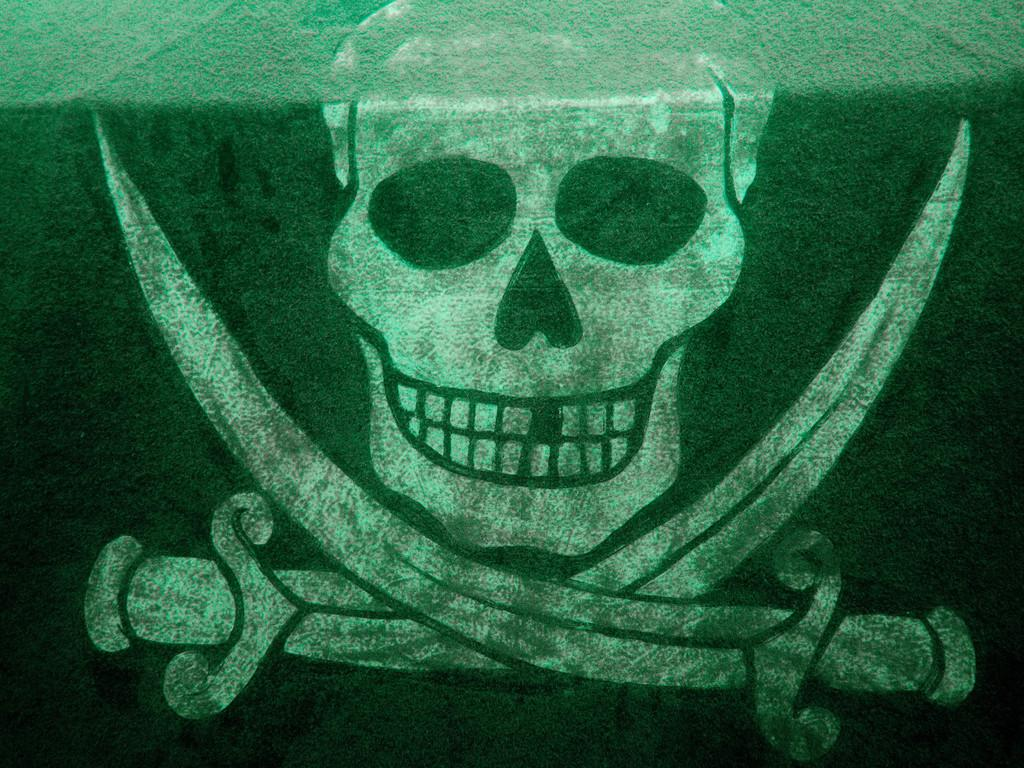Where was the image taken? The image was taken on the ground. What can be seen painted on the grass in the image? There is a skull and two swords painted on the grass in the image. What color is the grass at the bottom of the image? The grass at the bottom of the image is green. Can you see a ghost interacting with the skull in the image? There is no ghost present in the image; it only features a skull and swords painted on the grass. 